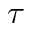Convert formula to latex. <formula><loc_0><loc_0><loc_500><loc_500>\tau</formula> 